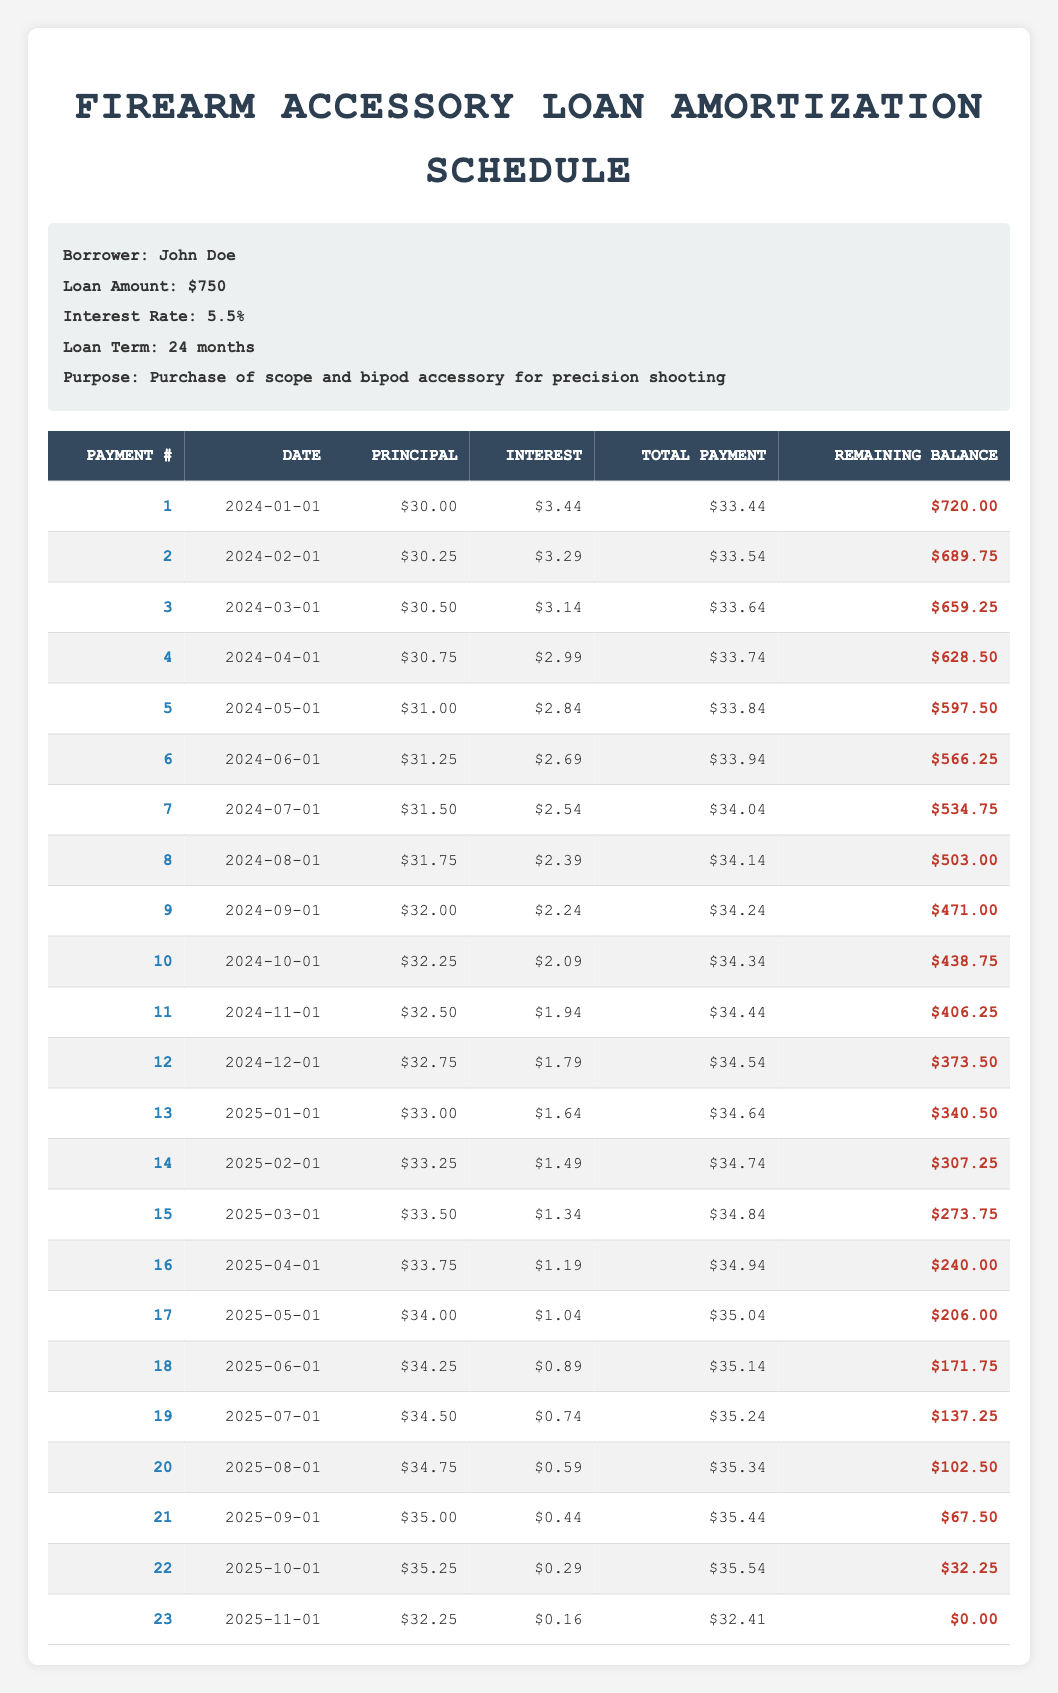What is the total loan amount for John Doe? The table specifies that the loan amount is listed in the "Loan Amount" section, which states "$750." Therefore, this is the total loan amount that John Doe borrowed.
Answer: 750 How much is the remaining balance after the 12th payment? To find the remaining balance after the 12th payment, we can look at the table under the "Remaining Balance" column for payment number 12, which shows "$373.50."
Answer: 373.50 What is the average principal payment across all payments? To calculate the average principal payment, we first sum all the principal payments: 30 + 30.25 + 30.50 + 30.75 + 31 + 31.25 + 31.50 + 31.75 + 32 + 32.25 + 32.50 + 32.75 + 33 + 33.25 + 33.50 + 33.75 + 34 + 34.25 + 34.50 + 34.75 + 35 + 35.25 + 32.25 = 726.00. There are 23 payments, so the average is 726.00 / 23 = 31.57.
Answer: 31.57 Did the interest payment decrease for each subsequent month? By inspecting the "Interest" column, we note the values of interest payments: they start at 3.44 and continue to decrease each month, ending at 0.16 for the last payment. Since all values drop, the interest payment indeed decreases each month.
Answer: Yes What is the total amount paid to date after the 18th payment? To find the total amount paid after the 18th payment, we sum all payments made up to that point. The payments are as follows: 33.44 + 33.54 + 33.64 + 33.74 + 33.84 + 33.94 + 34.04 + 34.14 + 34.24 + 34.34 + 34.44 + 34.54 + 34.64 + 34.74 + 34.84 + 34.94 + 35.04 + 35.14 = 610.58.
Answer: 610.58 What is the highest principal payment made in a single month? The "Principal" column shows the principal payments for each month. Looking through the values, the highest payment is 35.25, which occurs in payment number 22.
Answer: 35.25 